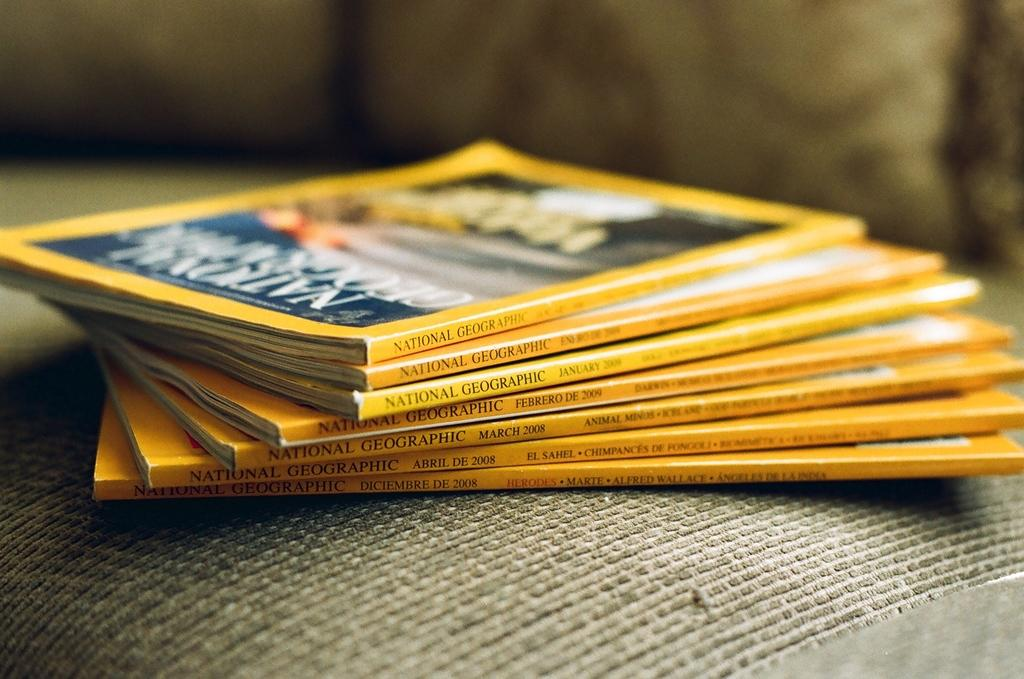<image>
Present a compact description of the photo's key features. A small stack of National Geographic magazines lay on a cushion. 